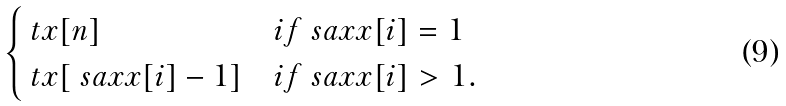Convert formula to latex. <formula><loc_0><loc_0><loc_500><loc_500>\begin{cases} \ t x [ n ] & i f \ s a x x [ i ] = 1 \\ \ t x [ \ s a x x [ i ] - 1 ] & i f \ s a x x [ i ] > 1 . \end{cases}</formula> 